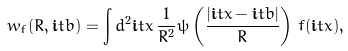Convert formula to latex. <formula><loc_0><loc_0><loc_500><loc_500>w _ { f } ( R , \mathbf i t { b } ) = \int d ^ { 2 } \mathbf i t { x } \, \frac { 1 } { R ^ { 2 } } \psi \left ( \frac { | \mathbf i t { x } - \mathbf i t { b } | } { R } \right ) \, f ( \mathbf i t { x } ) ,</formula> 